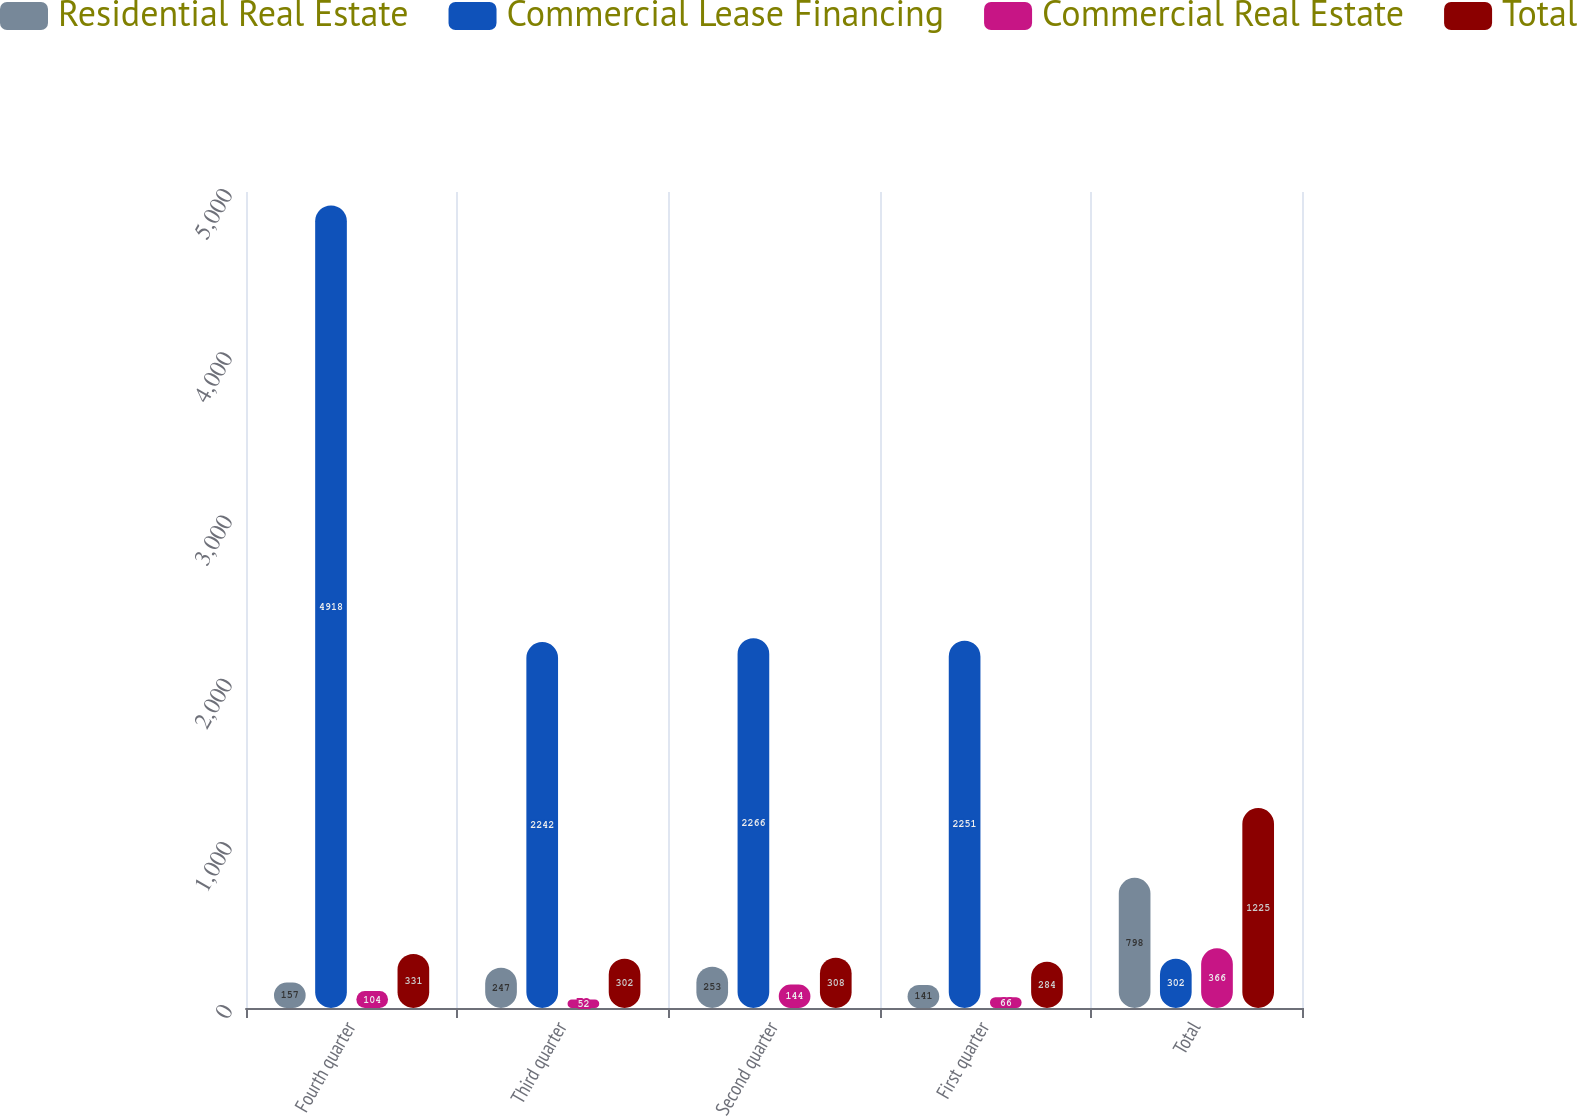Convert chart. <chart><loc_0><loc_0><loc_500><loc_500><stacked_bar_chart><ecel><fcel>Fourth quarter<fcel>Third quarter<fcel>Second quarter<fcel>First quarter<fcel>Total<nl><fcel>Residential Real Estate<fcel>157<fcel>247<fcel>253<fcel>141<fcel>798<nl><fcel>Commercial Lease Financing<fcel>4918<fcel>2242<fcel>2266<fcel>2251<fcel>302<nl><fcel>Commercial Real Estate<fcel>104<fcel>52<fcel>144<fcel>66<fcel>366<nl><fcel>Total<fcel>331<fcel>302<fcel>308<fcel>284<fcel>1225<nl></chart> 